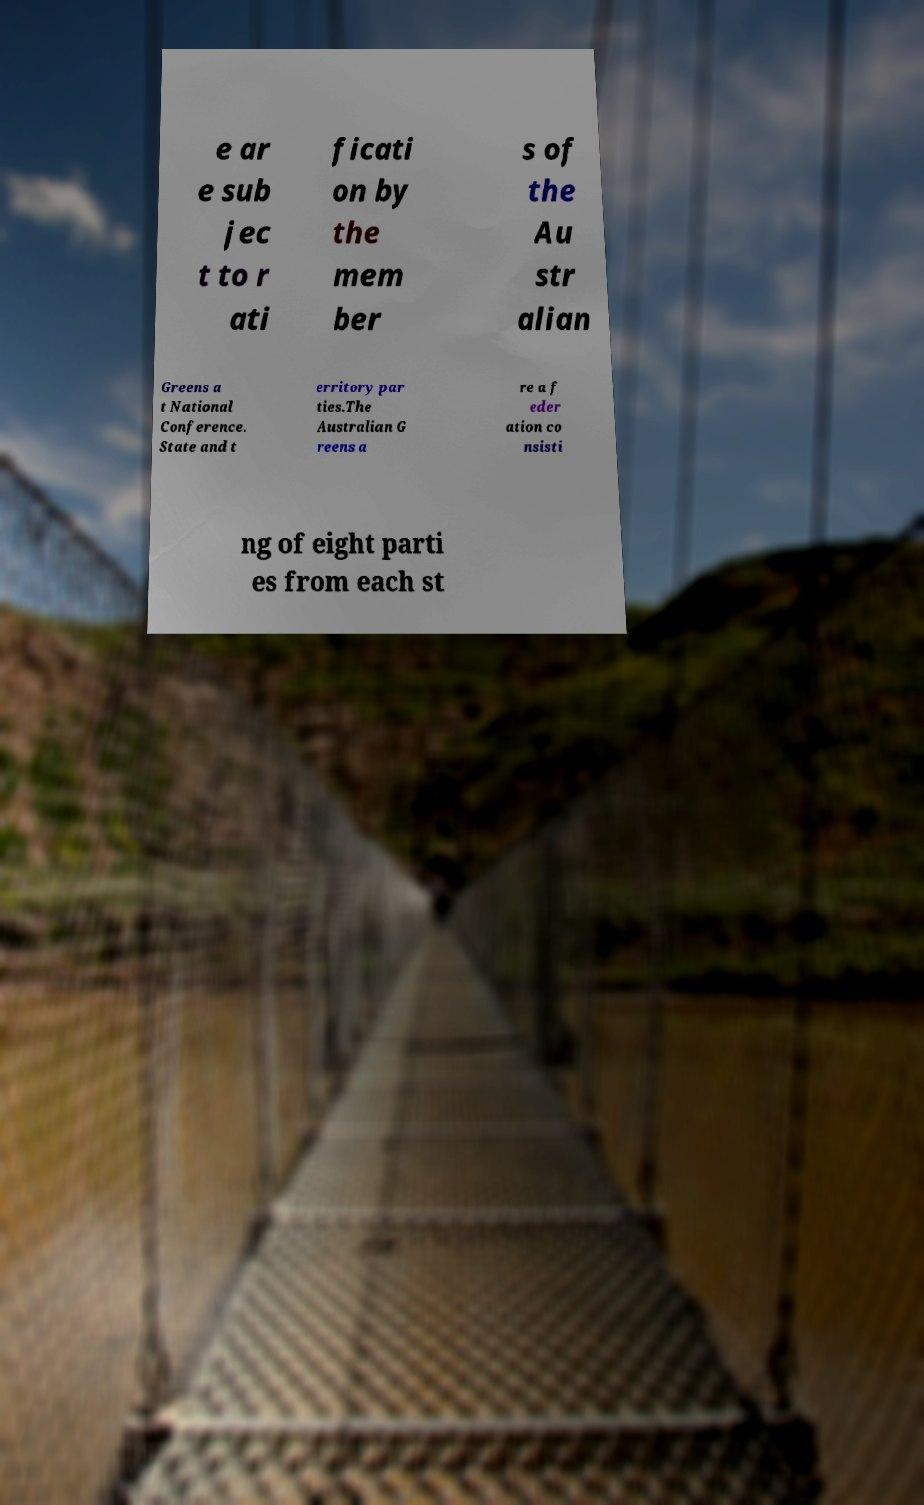There's text embedded in this image that I need extracted. Can you transcribe it verbatim? e ar e sub jec t to r ati ficati on by the mem ber s of the Au str alian Greens a t National Conference. State and t erritory par ties.The Australian G reens a re a f eder ation co nsisti ng of eight parti es from each st 